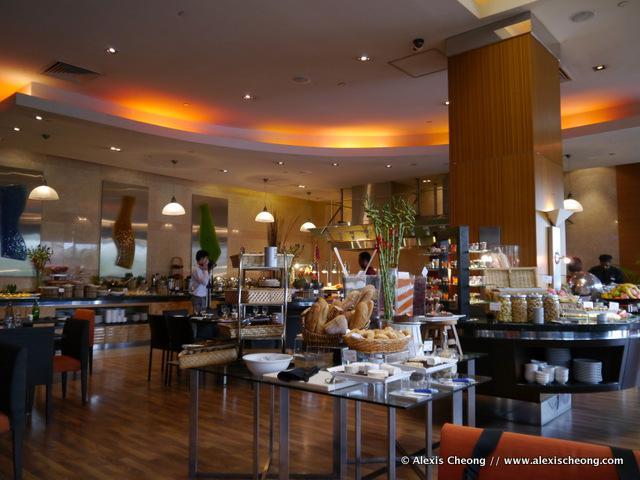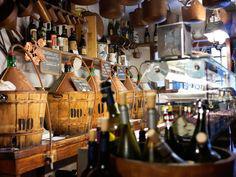The first image is the image on the left, the second image is the image on the right. For the images displayed, is the sentence "The foreground of an image features someone with an extended arm holding up multiple white plates filled with food." factually correct? Answer yes or no. No. The first image is the image on the left, the second image is the image on the right. For the images displayed, is the sentence "In at one image there is a server holding at least two white plates." factually correct? Answer yes or no. No. 